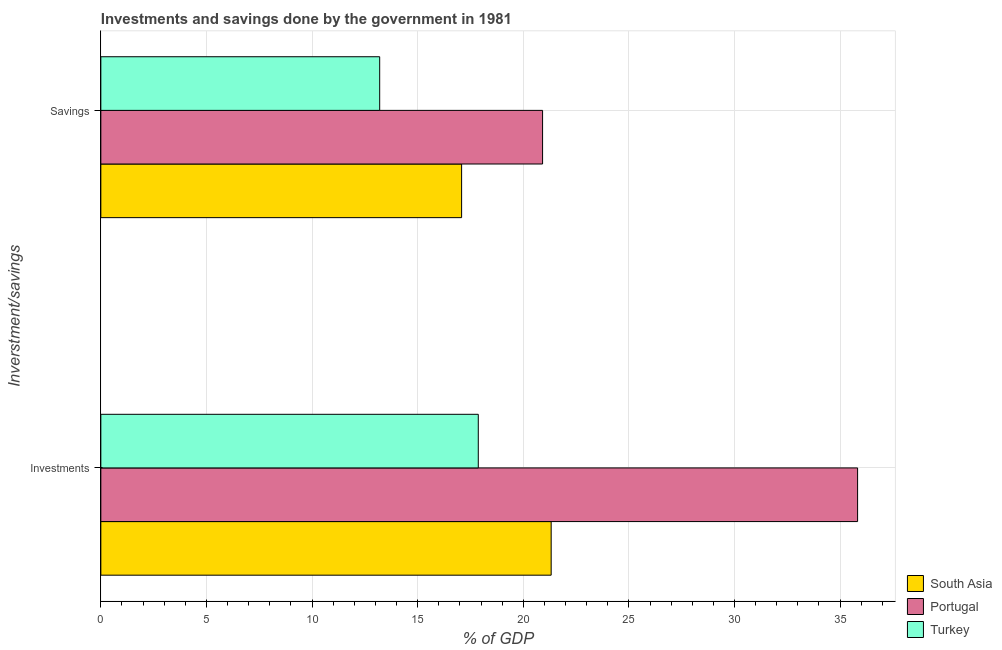Are the number of bars per tick equal to the number of legend labels?
Your answer should be compact. Yes. Are the number of bars on each tick of the Y-axis equal?
Offer a terse response. Yes. How many bars are there on the 2nd tick from the top?
Your answer should be compact. 3. How many bars are there on the 2nd tick from the bottom?
Offer a terse response. 3. What is the label of the 2nd group of bars from the top?
Your answer should be compact. Investments. What is the savings of government in Turkey?
Offer a very short reply. 13.2. Across all countries, what is the maximum savings of government?
Your response must be concise. 20.91. Across all countries, what is the minimum investments of government?
Provide a succinct answer. 17.87. What is the total savings of government in the graph?
Provide a short and direct response. 51.2. What is the difference between the investments of government in Portugal and that in South Asia?
Your response must be concise. 14.51. What is the difference between the investments of government in Portugal and the savings of government in Turkey?
Provide a succinct answer. 22.63. What is the average investments of government per country?
Provide a succinct answer. 25.01. What is the difference between the savings of government and investments of government in Portugal?
Provide a succinct answer. -14.91. In how many countries, is the savings of government greater than 11 %?
Give a very brief answer. 3. What is the ratio of the savings of government in Portugal to that in South Asia?
Make the answer very short. 1.22. Is the savings of government in Turkey less than that in South Asia?
Your answer should be compact. Yes. In how many countries, is the investments of government greater than the average investments of government taken over all countries?
Your answer should be compact. 1. What does the 1st bar from the top in Investments represents?
Offer a very short reply. Turkey. What does the 1st bar from the bottom in Investments represents?
Your answer should be very brief. South Asia. How many bars are there?
Ensure brevity in your answer.  6. Does the graph contain grids?
Offer a very short reply. Yes. Where does the legend appear in the graph?
Your answer should be compact. Bottom right. How many legend labels are there?
Keep it short and to the point. 3. What is the title of the graph?
Your answer should be compact. Investments and savings done by the government in 1981. What is the label or title of the X-axis?
Keep it short and to the point. % of GDP. What is the label or title of the Y-axis?
Ensure brevity in your answer.  Inverstment/savings. What is the % of GDP in South Asia in Investments?
Keep it short and to the point. 21.32. What is the % of GDP of Portugal in Investments?
Offer a terse response. 35.83. What is the % of GDP of Turkey in Investments?
Offer a terse response. 17.87. What is the % of GDP in South Asia in Savings?
Provide a short and direct response. 17.08. What is the % of GDP in Portugal in Savings?
Provide a short and direct response. 20.91. What is the % of GDP in Turkey in Savings?
Make the answer very short. 13.2. Across all Inverstment/savings, what is the maximum % of GDP in South Asia?
Give a very brief answer. 21.32. Across all Inverstment/savings, what is the maximum % of GDP of Portugal?
Offer a very short reply. 35.83. Across all Inverstment/savings, what is the maximum % of GDP of Turkey?
Offer a terse response. 17.87. Across all Inverstment/savings, what is the minimum % of GDP in South Asia?
Your answer should be very brief. 17.08. Across all Inverstment/savings, what is the minimum % of GDP of Portugal?
Your response must be concise. 20.91. Across all Inverstment/savings, what is the minimum % of GDP of Turkey?
Provide a short and direct response. 13.2. What is the total % of GDP of South Asia in the graph?
Make the answer very short. 38.4. What is the total % of GDP of Portugal in the graph?
Provide a succinct answer. 56.74. What is the total % of GDP of Turkey in the graph?
Offer a very short reply. 31.07. What is the difference between the % of GDP in South Asia in Investments and that in Savings?
Offer a very short reply. 4.24. What is the difference between the % of GDP in Portugal in Investments and that in Savings?
Provide a succinct answer. 14.91. What is the difference between the % of GDP in Turkey in Investments and that in Savings?
Offer a terse response. 4.67. What is the difference between the % of GDP in South Asia in Investments and the % of GDP in Portugal in Savings?
Offer a very short reply. 0.41. What is the difference between the % of GDP of South Asia in Investments and the % of GDP of Turkey in Savings?
Give a very brief answer. 8.12. What is the difference between the % of GDP of Portugal in Investments and the % of GDP of Turkey in Savings?
Offer a very short reply. 22.63. What is the average % of GDP in South Asia per Inverstment/savings?
Offer a very short reply. 19.2. What is the average % of GDP of Portugal per Inverstment/savings?
Your answer should be very brief. 28.37. What is the average % of GDP of Turkey per Inverstment/savings?
Your answer should be very brief. 15.54. What is the difference between the % of GDP in South Asia and % of GDP in Portugal in Investments?
Your response must be concise. -14.51. What is the difference between the % of GDP of South Asia and % of GDP of Turkey in Investments?
Give a very brief answer. 3.45. What is the difference between the % of GDP of Portugal and % of GDP of Turkey in Investments?
Give a very brief answer. 17.96. What is the difference between the % of GDP in South Asia and % of GDP in Portugal in Savings?
Give a very brief answer. -3.83. What is the difference between the % of GDP in South Asia and % of GDP in Turkey in Savings?
Ensure brevity in your answer.  3.88. What is the difference between the % of GDP in Portugal and % of GDP in Turkey in Savings?
Ensure brevity in your answer.  7.71. What is the ratio of the % of GDP in South Asia in Investments to that in Savings?
Ensure brevity in your answer.  1.25. What is the ratio of the % of GDP of Portugal in Investments to that in Savings?
Offer a terse response. 1.71. What is the ratio of the % of GDP of Turkey in Investments to that in Savings?
Make the answer very short. 1.35. What is the difference between the highest and the second highest % of GDP in South Asia?
Keep it short and to the point. 4.24. What is the difference between the highest and the second highest % of GDP in Portugal?
Make the answer very short. 14.91. What is the difference between the highest and the second highest % of GDP in Turkey?
Ensure brevity in your answer.  4.67. What is the difference between the highest and the lowest % of GDP of South Asia?
Provide a succinct answer. 4.24. What is the difference between the highest and the lowest % of GDP in Portugal?
Make the answer very short. 14.91. What is the difference between the highest and the lowest % of GDP in Turkey?
Offer a very short reply. 4.67. 